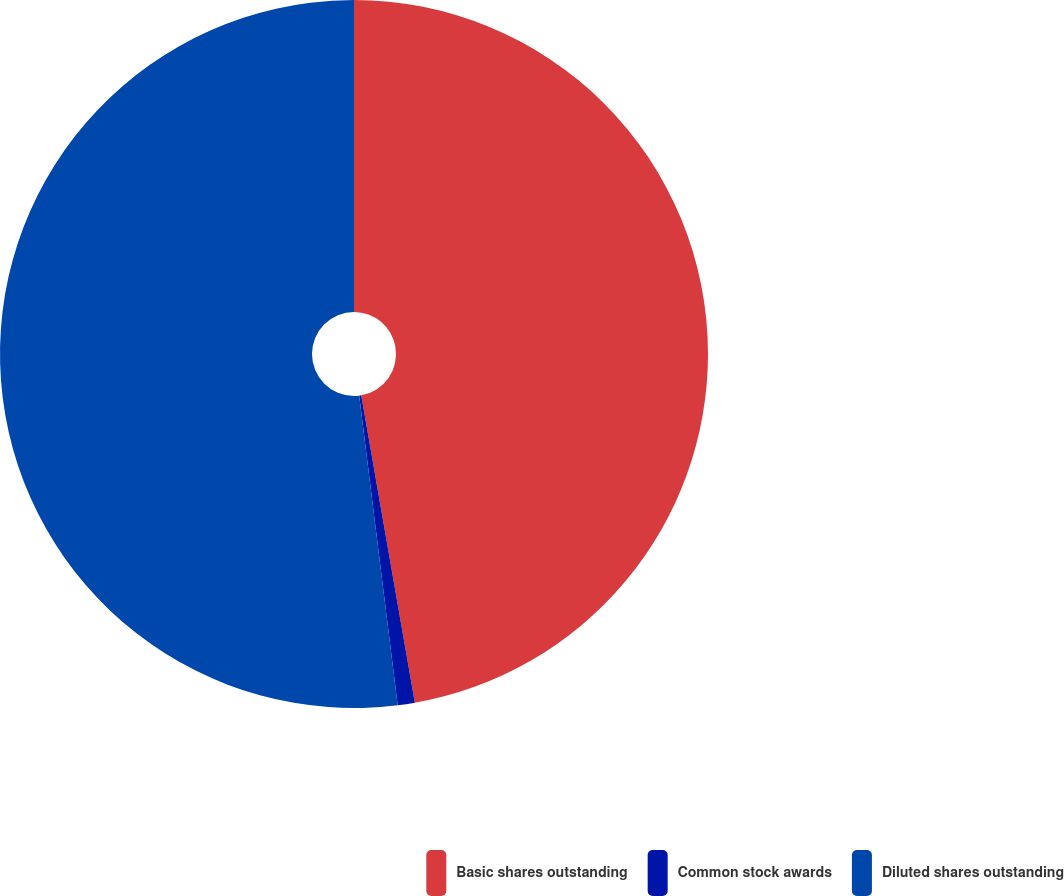Convert chart. <chart><loc_0><loc_0><loc_500><loc_500><pie_chart><fcel>Basic shares outstanding<fcel>Common stock awards<fcel>Diluted shares outstanding<nl><fcel>47.25%<fcel>0.78%<fcel>51.97%<nl></chart> 